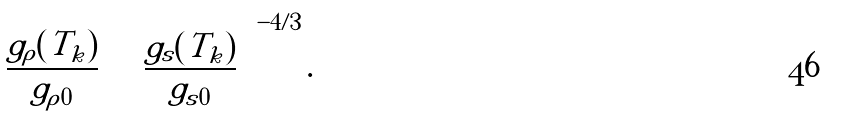<formula> <loc_0><loc_0><loc_500><loc_500>\left ( \frac { g _ { \rho } ( T _ { k } ) } { g _ { \rho 0 } } \right ) \left ( \frac { g _ { s } ( T _ { k } ) } { g _ { s 0 } } \right ) ^ { - 4 / 3 } .</formula> 